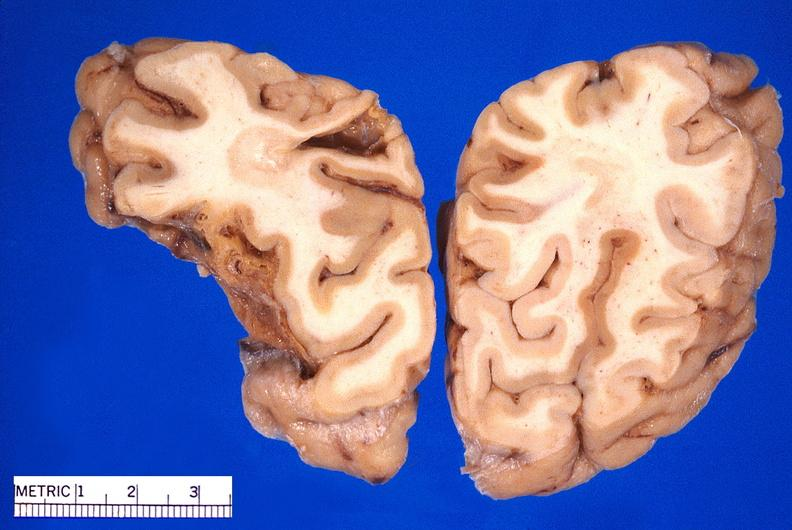does this image show brain, old infarcts, embolic?
Answer the question using a single word or phrase. Yes 